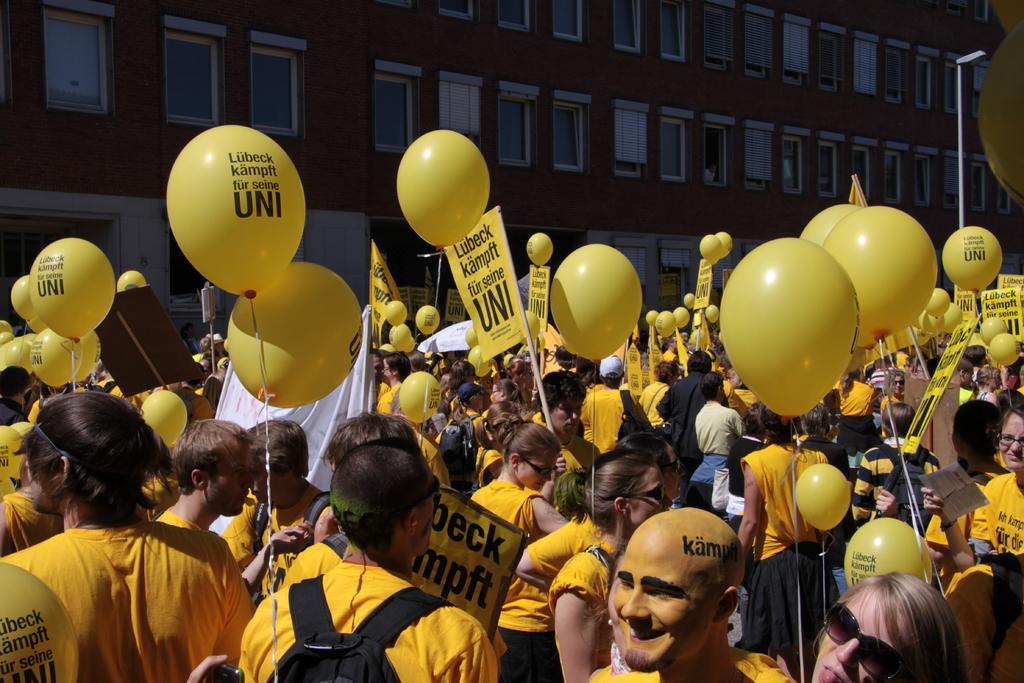Could you give a brief overview of what you see in this image? In this image I can see people are standing. These people are wearing yellow color clothes. I can also see yellow color balloons and street light. In the background I can see a building which has windows. 